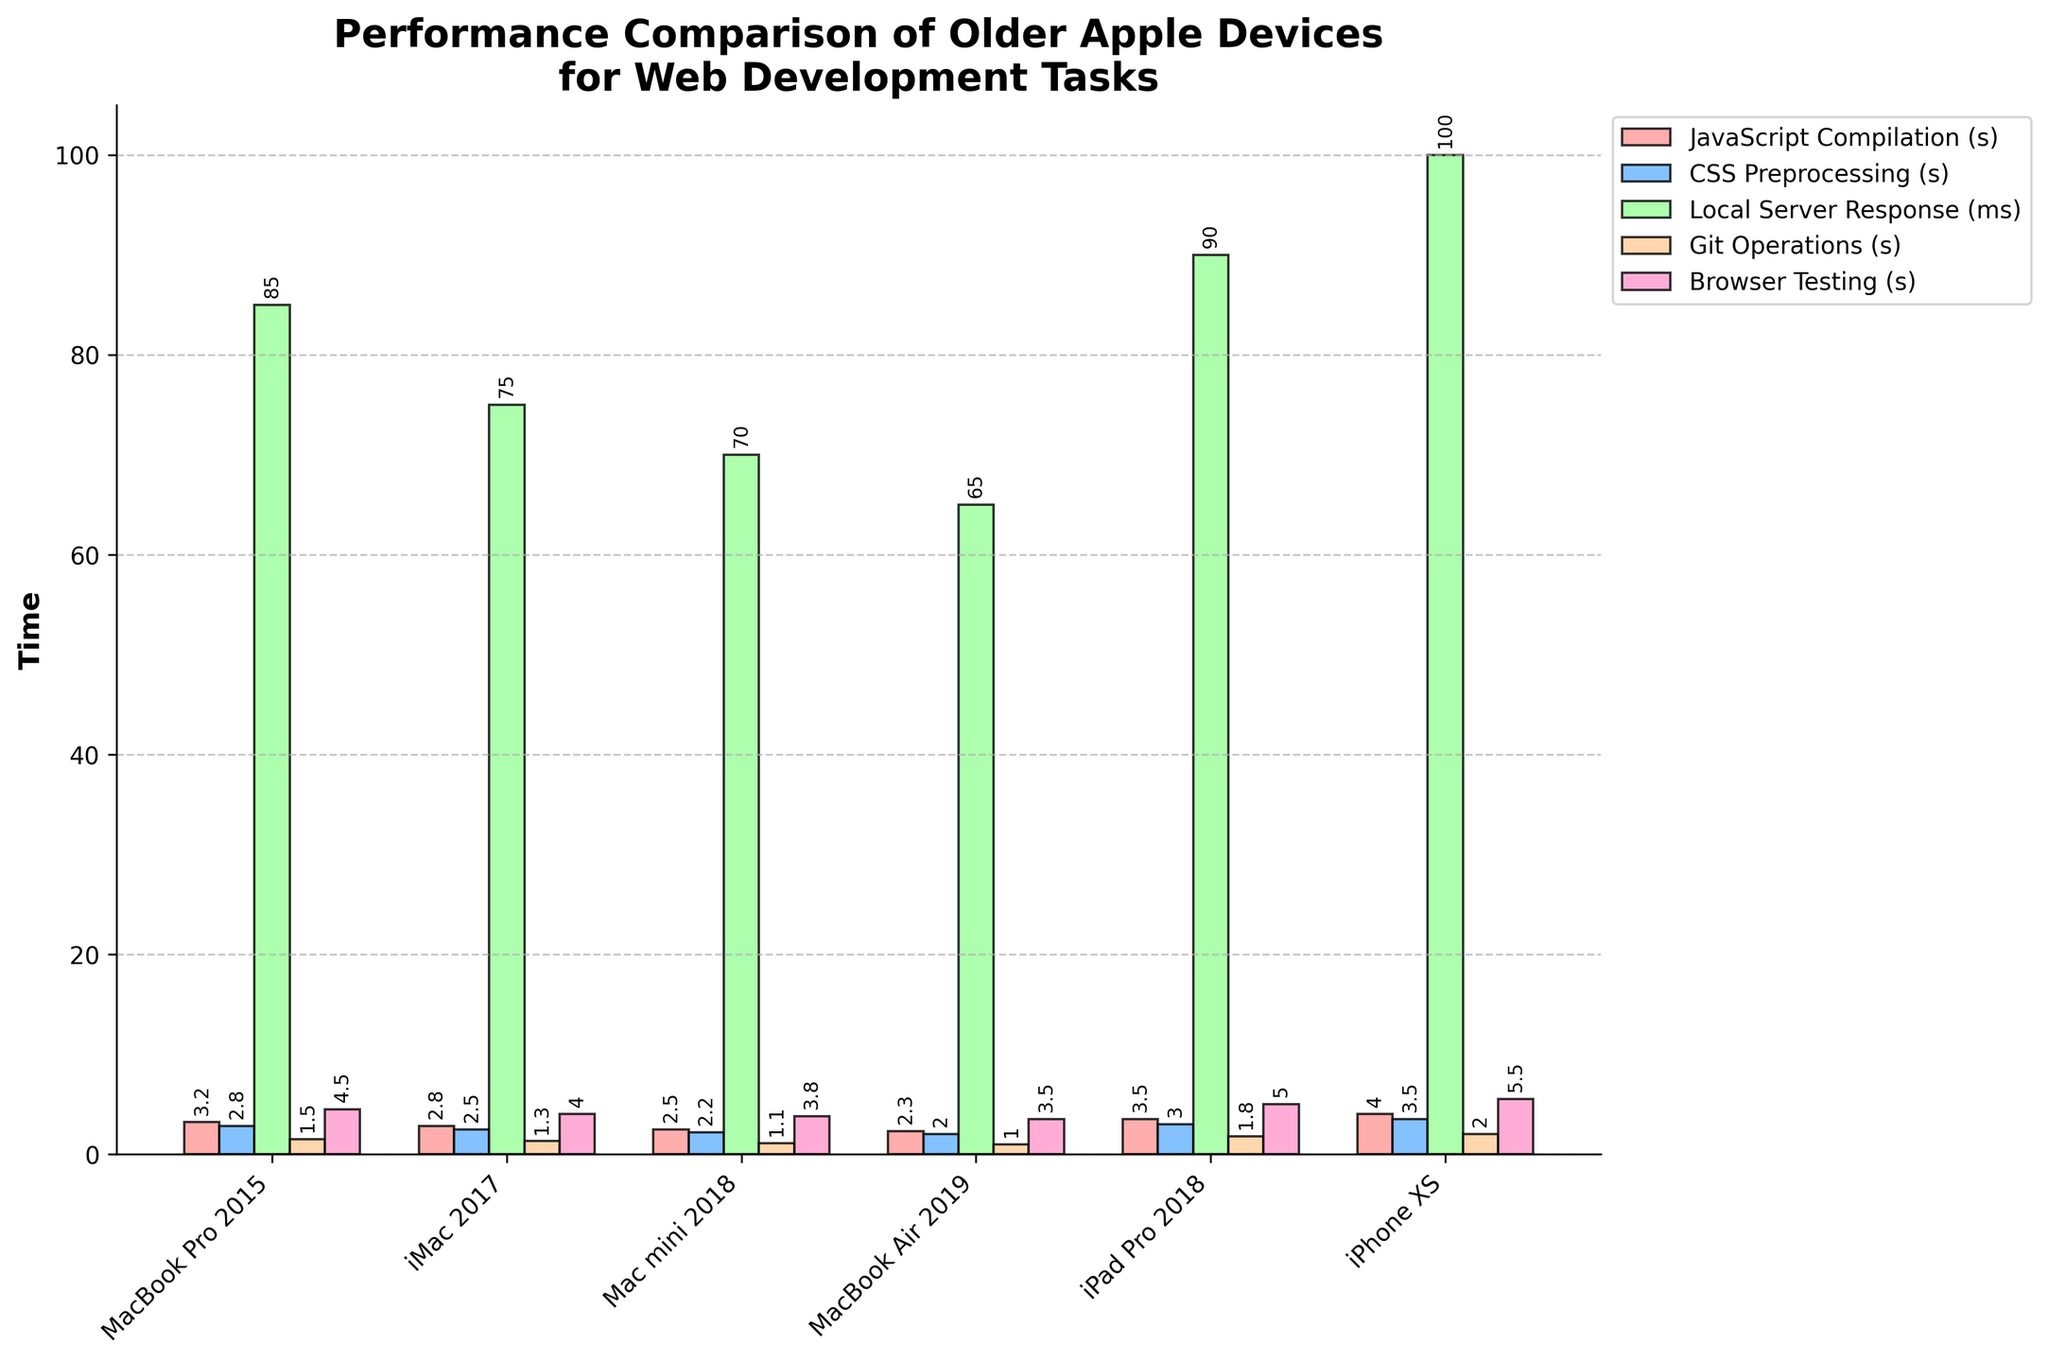What is the device with the fastest JavaScript Compilation time? Looking at the JavaScript Compilation bars, the shortest bar indicates the fastest time. The MacBook Air 2019 has the shortest bar for this task.
Answer: MacBook Air 2019 Which device has the slowest Local Server Response time? The tallest bar under Local Server Response represents the slowest response time. The iPhone XS has the tallest bar for this task.
Answer: iPhone XS What is the total time taken for JavaScript Compilation and CSS Preprocessing on the iPad Pro 2018? For the iPad Pro 2018, the JavaScript Compilation time is 3.5 seconds and the CSS Preprocessing time is 3.0 seconds. Adding them up: 3.5 + 3.0 = 6.5 seconds.
Answer: 6.5 seconds Which device performs better for Git Operations, Mac mini 2018 or iMac 2017? Comparing the Git Operations bars for both devices, the Mac mini 2018 has a shorter bar (1.1 seconds) compared to the iMac 2017 (1.3 seconds), indicating better performance.
Answer: Mac mini 2018 What is the average Browser Testing time across all devices? List the Browser Testing times: 4.5, 4.0, 3.8, 3.5, 5.0, and 5.5 seconds. Calculate the average: (4.5 + 4.0 + 3.8 + 3.5 + 5.0 + 5.5) / 6 = 26.3 / 6 = 4.3833 seconds.
Answer: 4.38 seconds Which task has the greatest performance difference between the MacBook Pro 2015 and iPhone XS? Checking each task's difference: JavaScript Compilation (4.0 - 3.2 = 0.8), CSS Preprocessing (3.5 - 2.8 = 0.7), Local Server Response (100 - 85 = 15), Git Operations (2.0 - 1.5 = 0.5), Browser Testing (5.5 - 4.5 = 1.0). Local Server Response has the greatest difference of 15 milliseconds.
Answer: Local Server Response How does the browser testing performance of the MacBook Air 2019 compare to the Mac mini 2018? The Browser Testing bar for Mac mini 2018 is at 3.8 seconds while for MacBook Air 2019 it is at 3.5 seconds. MacBook Air 2019 performs better with a shorter time.
Answer: MacBook Air 2019 Which device shows the most balanced performance across all tasks? By visually inspecting the heights of the bars, the Mac mini 2018 and MacBook Air 2019 seem to have the most balanced and relatively lower bars across all tasks, indicating consistent performance.
Answer: Mac mini 2018 / MacBook Air 2019 